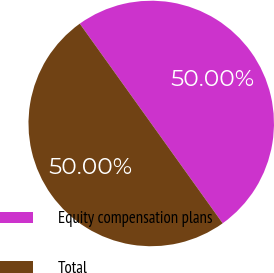Convert chart. <chart><loc_0><loc_0><loc_500><loc_500><pie_chart><fcel>Equity compensation plans<fcel>Total<nl><fcel>50.0%<fcel>50.0%<nl></chart> 